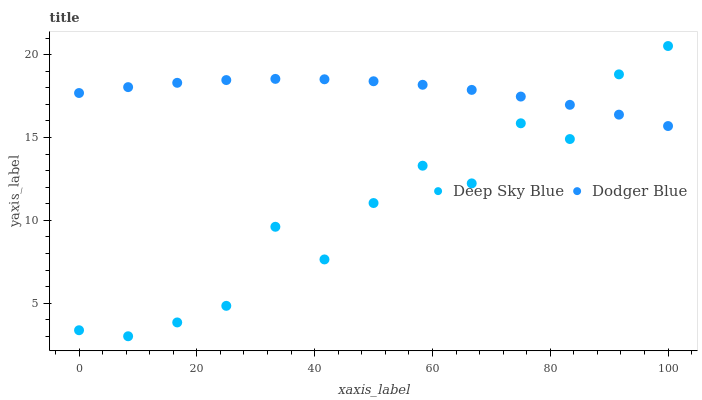Does Deep Sky Blue have the minimum area under the curve?
Answer yes or no. Yes. Does Dodger Blue have the maximum area under the curve?
Answer yes or no. Yes. Does Deep Sky Blue have the maximum area under the curve?
Answer yes or no. No. Is Dodger Blue the smoothest?
Answer yes or no. Yes. Is Deep Sky Blue the roughest?
Answer yes or no. Yes. Is Deep Sky Blue the smoothest?
Answer yes or no. No. Does Deep Sky Blue have the lowest value?
Answer yes or no. Yes. Does Deep Sky Blue have the highest value?
Answer yes or no. Yes. Does Dodger Blue intersect Deep Sky Blue?
Answer yes or no. Yes. Is Dodger Blue less than Deep Sky Blue?
Answer yes or no. No. Is Dodger Blue greater than Deep Sky Blue?
Answer yes or no. No. 